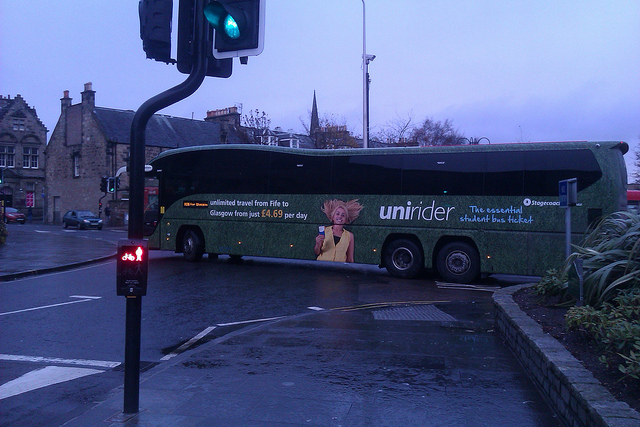If I wanted to use the bus service, how much would I be expected to pay daily? For daily usage of the bus service, you would expect to pay £4.50, offering unlimited travel between the areas of Fife and Glasgow. 